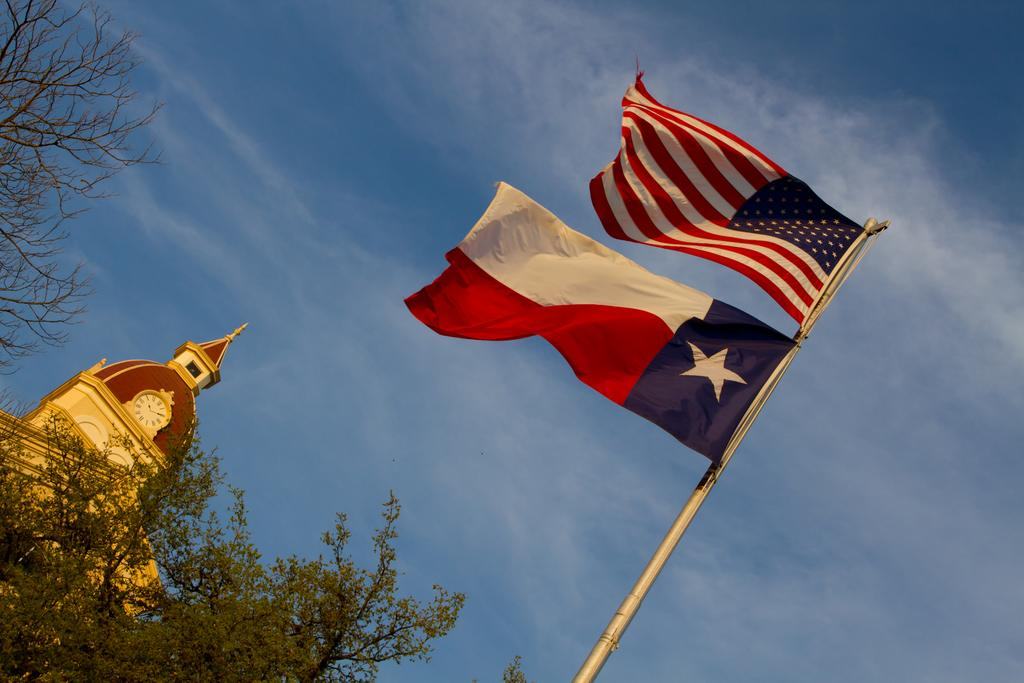What can be seen flying in the image? There are flags in the image. What is supporting the flags in the image? There is a pole in the image. What type of vegetation is on the left side of the image? There are trees on the left side of the image. What structure is on the left side of the image? There is a building on the left side of the image. What is visible in the background of the image? The sky is visible in the background of the image. How many clovers are growing on the pole in the image? There are no clovers present in the image; the pole is supporting flags. What type of company is represented by the flags in the image? There is no indication of a specific company represented by the flags in the image. 